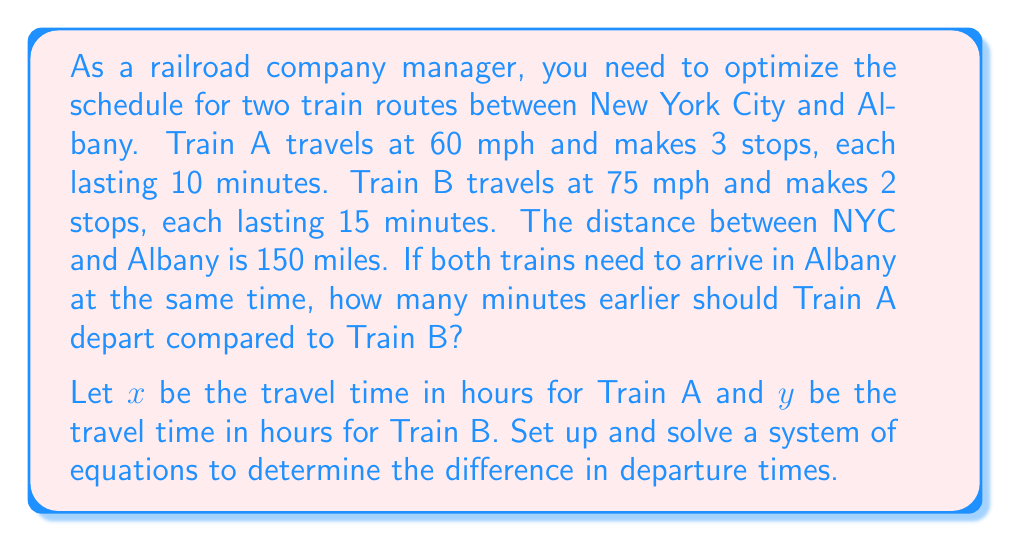Can you solve this math problem? Let's approach this step-by-step:

1) First, let's set up equations for each train's journey:

   For Train A: $60x = 150 + 60(0.5)$ (distance = speed * time + time spent at stops)
   For Train B: $75y = 150 + 75(0.5)$ (distance = speed * time + time spent at stops)

2) Simplify these equations:
   
   Train A: $60x = 180$ or $x = 3$
   Train B: $75y = 187.5$ or $y = 2.5$

3) The difference in travel time is: $3 - 2.5 = 0.5$ hours

4) Convert 0.5 hours to minutes: $0.5 * 60 = 30$ minutes

Therefore, Train A should depart 30 minutes earlier than Train B to arrive at the same time.
Answer: 30 minutes 